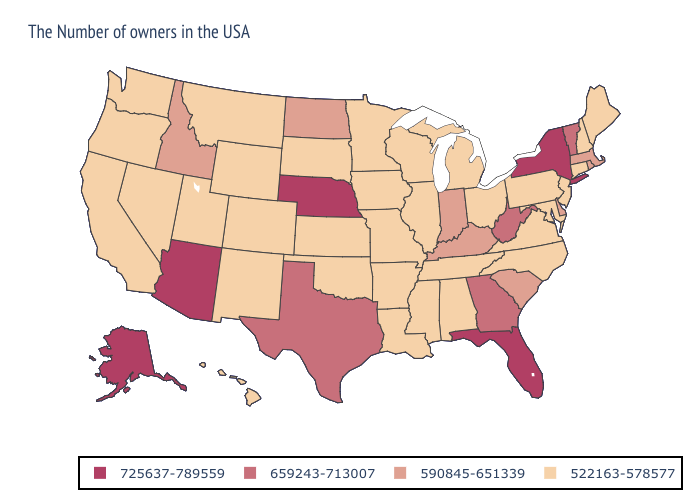What is the value of Colorado?
Be succinct. 522163-578577. Name the states that have a value in the range 590845-651339?
Be succinct. Massachusetts, Rhode Island, Delaware, South Carolina, Kentucky, Indiana, North Dakota, Idaho. What is the highest value in states that border Maryland?
Short answer required. 659243-713007. What is the value of Louisiana?
Quick response, please. 522163-578577. Does Montana have a higher value than Texas?
Be succinct. No. Among the states that border Missouri , which have the lowest value?
Quick response, please. Tennessee, Illinois, Arkansas, Iowa, Kansas, Oklahoma. Name the states that have a value in the range 522163-578577?
Be succinct. Maine, New Hampshire, Connecticut, New Jersey, Maryland, Pennsylvania, Virginia, North Carolina, Ohio, Michigan, Alabama, Tennessee, Wisconsin, Illinois, Mississippi, Louisiana, Missouri, Arkansas, Minnesota, Iowa, Kansas, Oklahoma, South Dakota, Wyoming, Colorado, New Mexico, Utah, Montana, Nevada, California, Washington, Oregon, Hawaii. Does the map have missing data?
Keep it brief. No. Name the states that have a value in the range 725637-789559?
Concise answer only. New York, Florida, Nebraska, Arizona, Alaska. Does Pennsylvania have the same value as Georgia?
Give a very brief answer. No. Does the map have missing data?
Answer briefly. No. What is the value of Iowa?
Quick response, please. 522163-578577. What is the value of Texas?
Keep it brief. 659243-713007. What is the value of South Carolina?
Concise answer only. 590845-651339. What is the value of Utah?
Quick response, please. 522163-578577. 